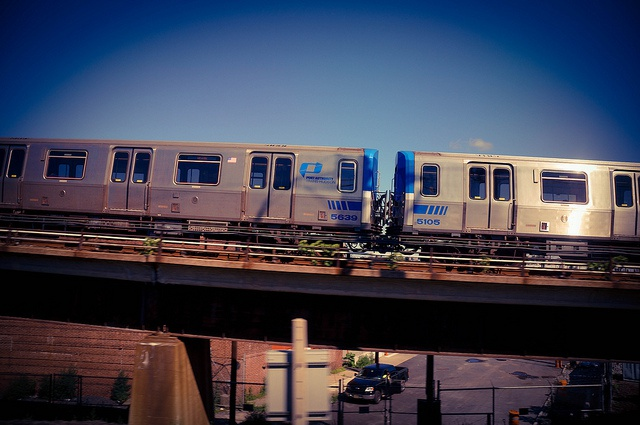Describe the objects in this image and their specific colors. I can see train in navy, black, and gray tones, truck in navy, black, gray, and purple tones, and car in navy, black, gray, and purple tones in this image. 